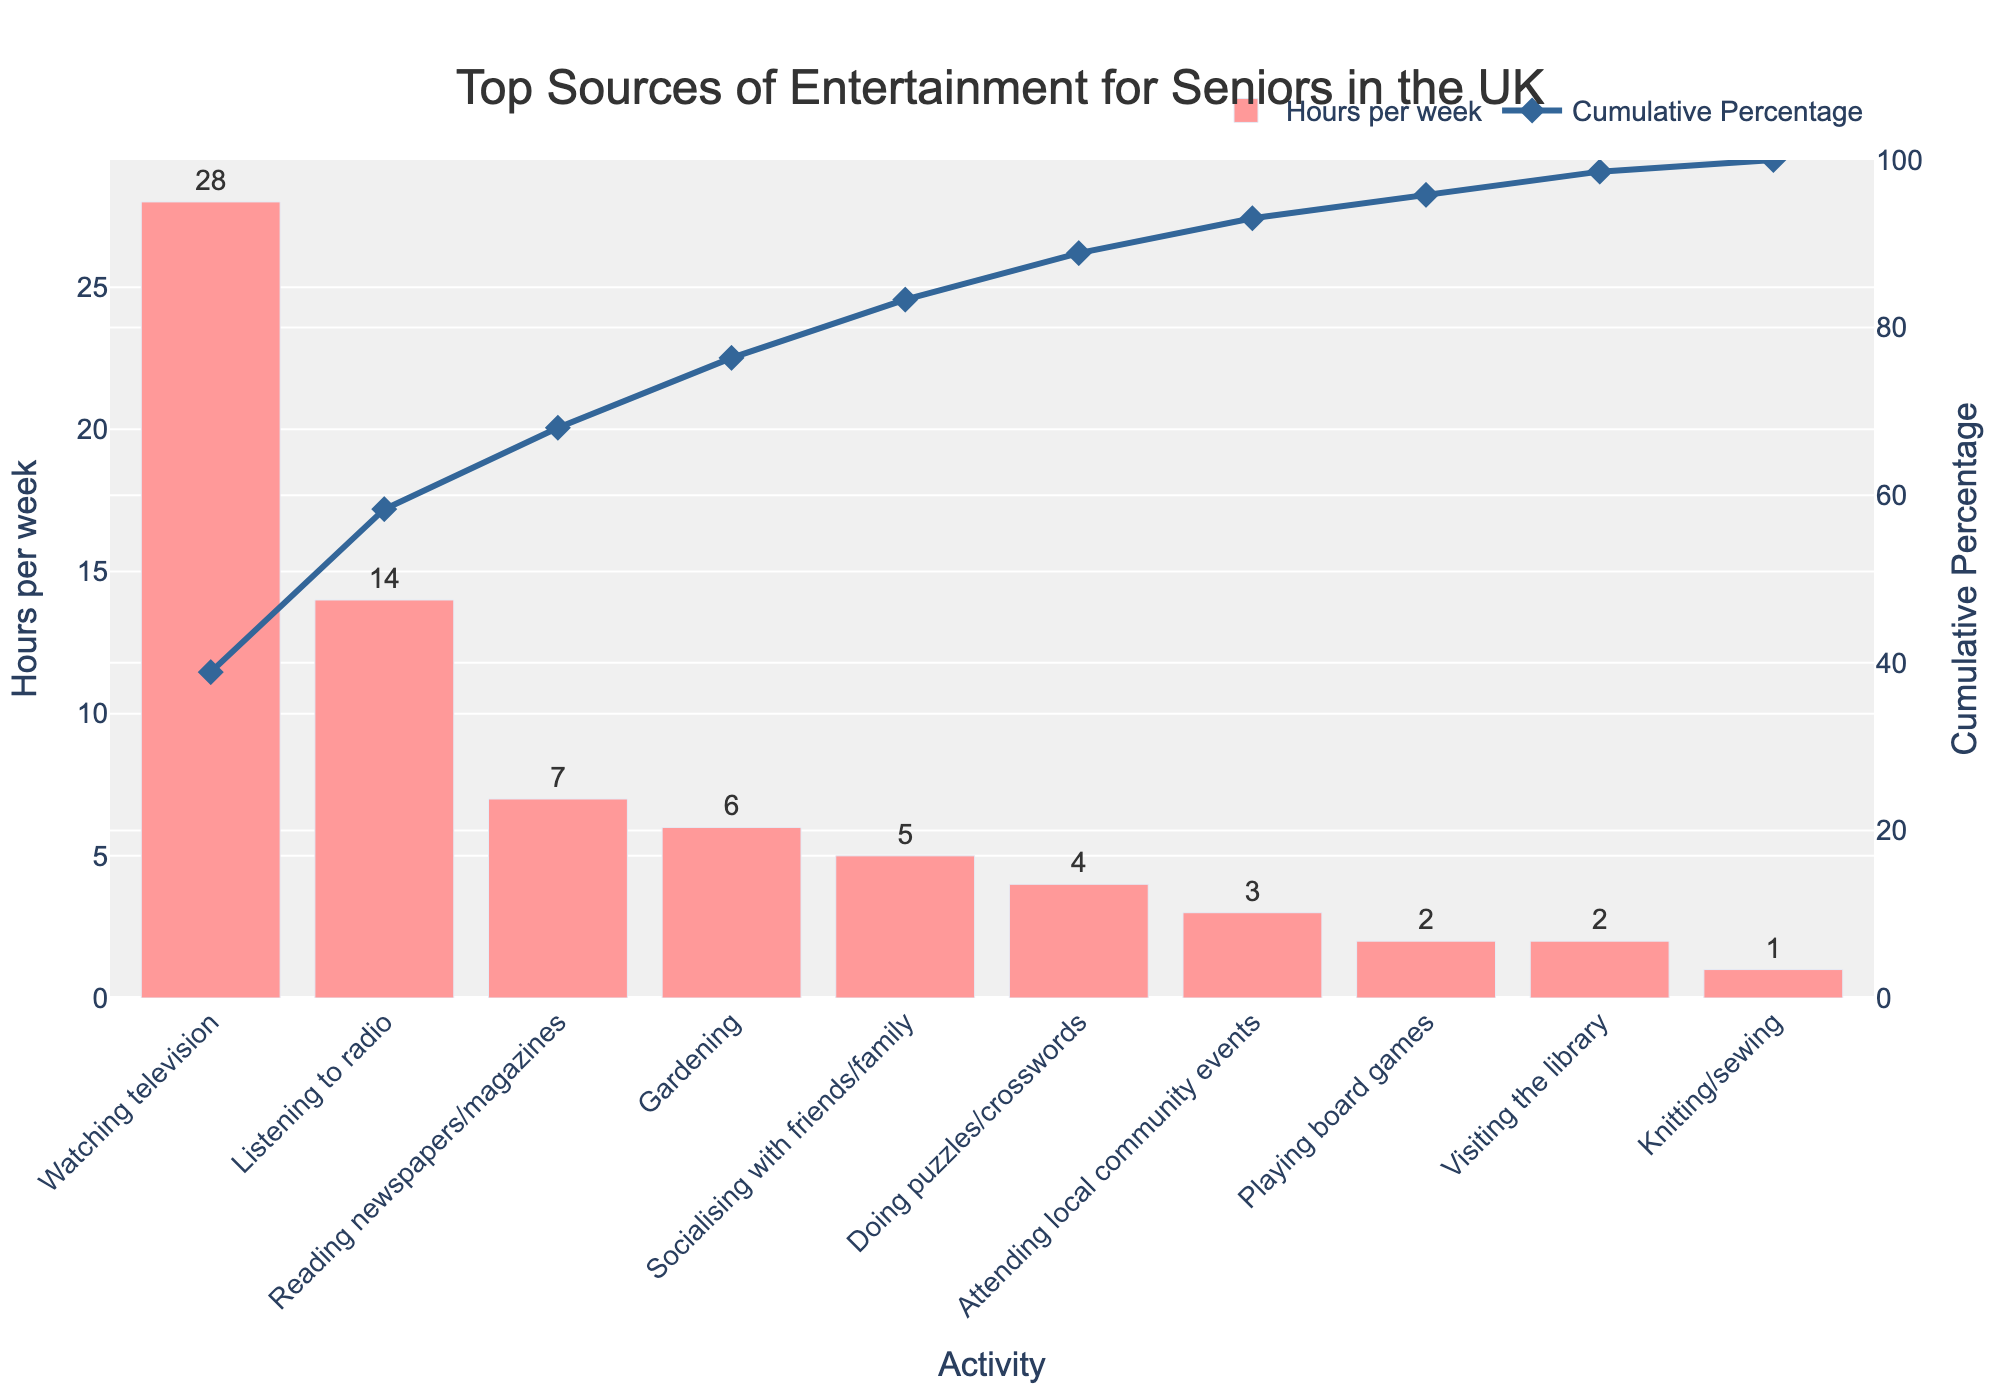what is the title of the chart? The title appears at the top of the chart, providing a summary of the information being represented. In this case, the title is "Top Sources of Entertainment for Seniors in the UK".
Answer: Top Sources of Entertainment for Seniors in the UK What activity occupies the most hours per week? By observing the height of the bars representing "Hours per week", the tallest bar indicates the activity with the most hours. "Watching television" has the tallest bar.
Answer: Watching television What are the total hours spent on gardening and reading newspapers/magazines combined? To get the total, sum the hours spent on gardening (6 hours) and reading newspapers/magazines (7 hours). 6 + 7 = 13.
Answer: 13 Which activity contributes exactly 2% to the cumulative percentage? By looking at the cumulative percentage line, the activity that aligns with the 2% mark can be identified. "Knitting/sewing" aligns with that mark.
Answer: Knitting/sewing Compare the hours spent on socialising with friends/family and playing board games. Which one is greater and by how much? Socialising with friends/family takes 5 hours, while playing board games takes 2 hours. To find the difference: 5 - 2 = 3. Socialising with friends/family occupies 3 more hours.
Answer: Socialising with friends/family, 3 What does the cumulative percentage line represent? The cumulative percentage line illustrates the running total of the hours for each activity as a proportion of the total hours, helping to understand the overall contribution of each activity.
Answer: It shows the running total as a proportion of the total hours Which activity is the third most popular among seniors? By examining the bars that represent "Hours per week" in descending order, the third tallest bar corresponds to the third most popular activity. That activity is "Reading newspapers/magazines" with 7 hours.
Answer: Reading newspapers/magazines How many activities occupy 10 hours or more per week? By looking at the bar heights, we can see that only "Watching television" (28 hours) and "Listening to radio" (14 hours) fit the criteria. So, there are 2 such activities.
Answer: 2 What percentage of the total hours is spent on the top three activities combined? The top three activities are "Watching television" (28 hours), "Listening to radio" (14 hours), and "Reading newspapers/magazines" (7 hours). Their combined hours are 28 + 14 + 7 = 49 hours. The total weekly hours for all activities is 72. To find the percentage: (49/72) * 100 = 68.06%.
Answer: 68.06% 